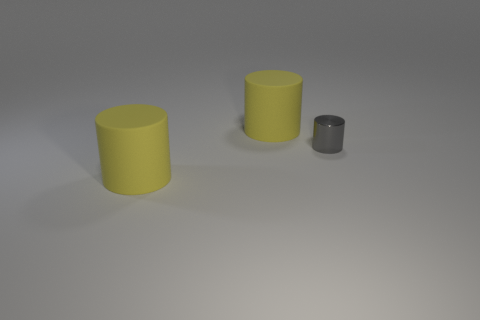What is the color of the tiny metal cylinder?
Offer a very short reply. Gray. Are there any tiny cylinders that are to the right of the rubber object behind the gray shiny thing?
Your response must be concise. Yes. How many other things are the same color as the small metal cylinder?
Provide a short and direct response. 0. The gray metal cylinder is what size?
Your response must be concise. Small. Are there any big purple rubber cylinders?
Provide a succinct answer. No. Is there any other thing that is the same size as the metal thing?
Ensure brevity in your answer.  No. What number of large things are to the left of the tiny metal cylinder?
Keep it short and to the point. 2. There is a yellow thing that is behind the gray metal thing; is it the same size as the small gray shiny thing?
Your response must be concise. No. What shape is the large yellow object behind the gray cylinder?
Offer a very short reply. Cylinder. What number of big yellow rubber objects are the same shape as the small metal object?
Offer a terse response. 2. 